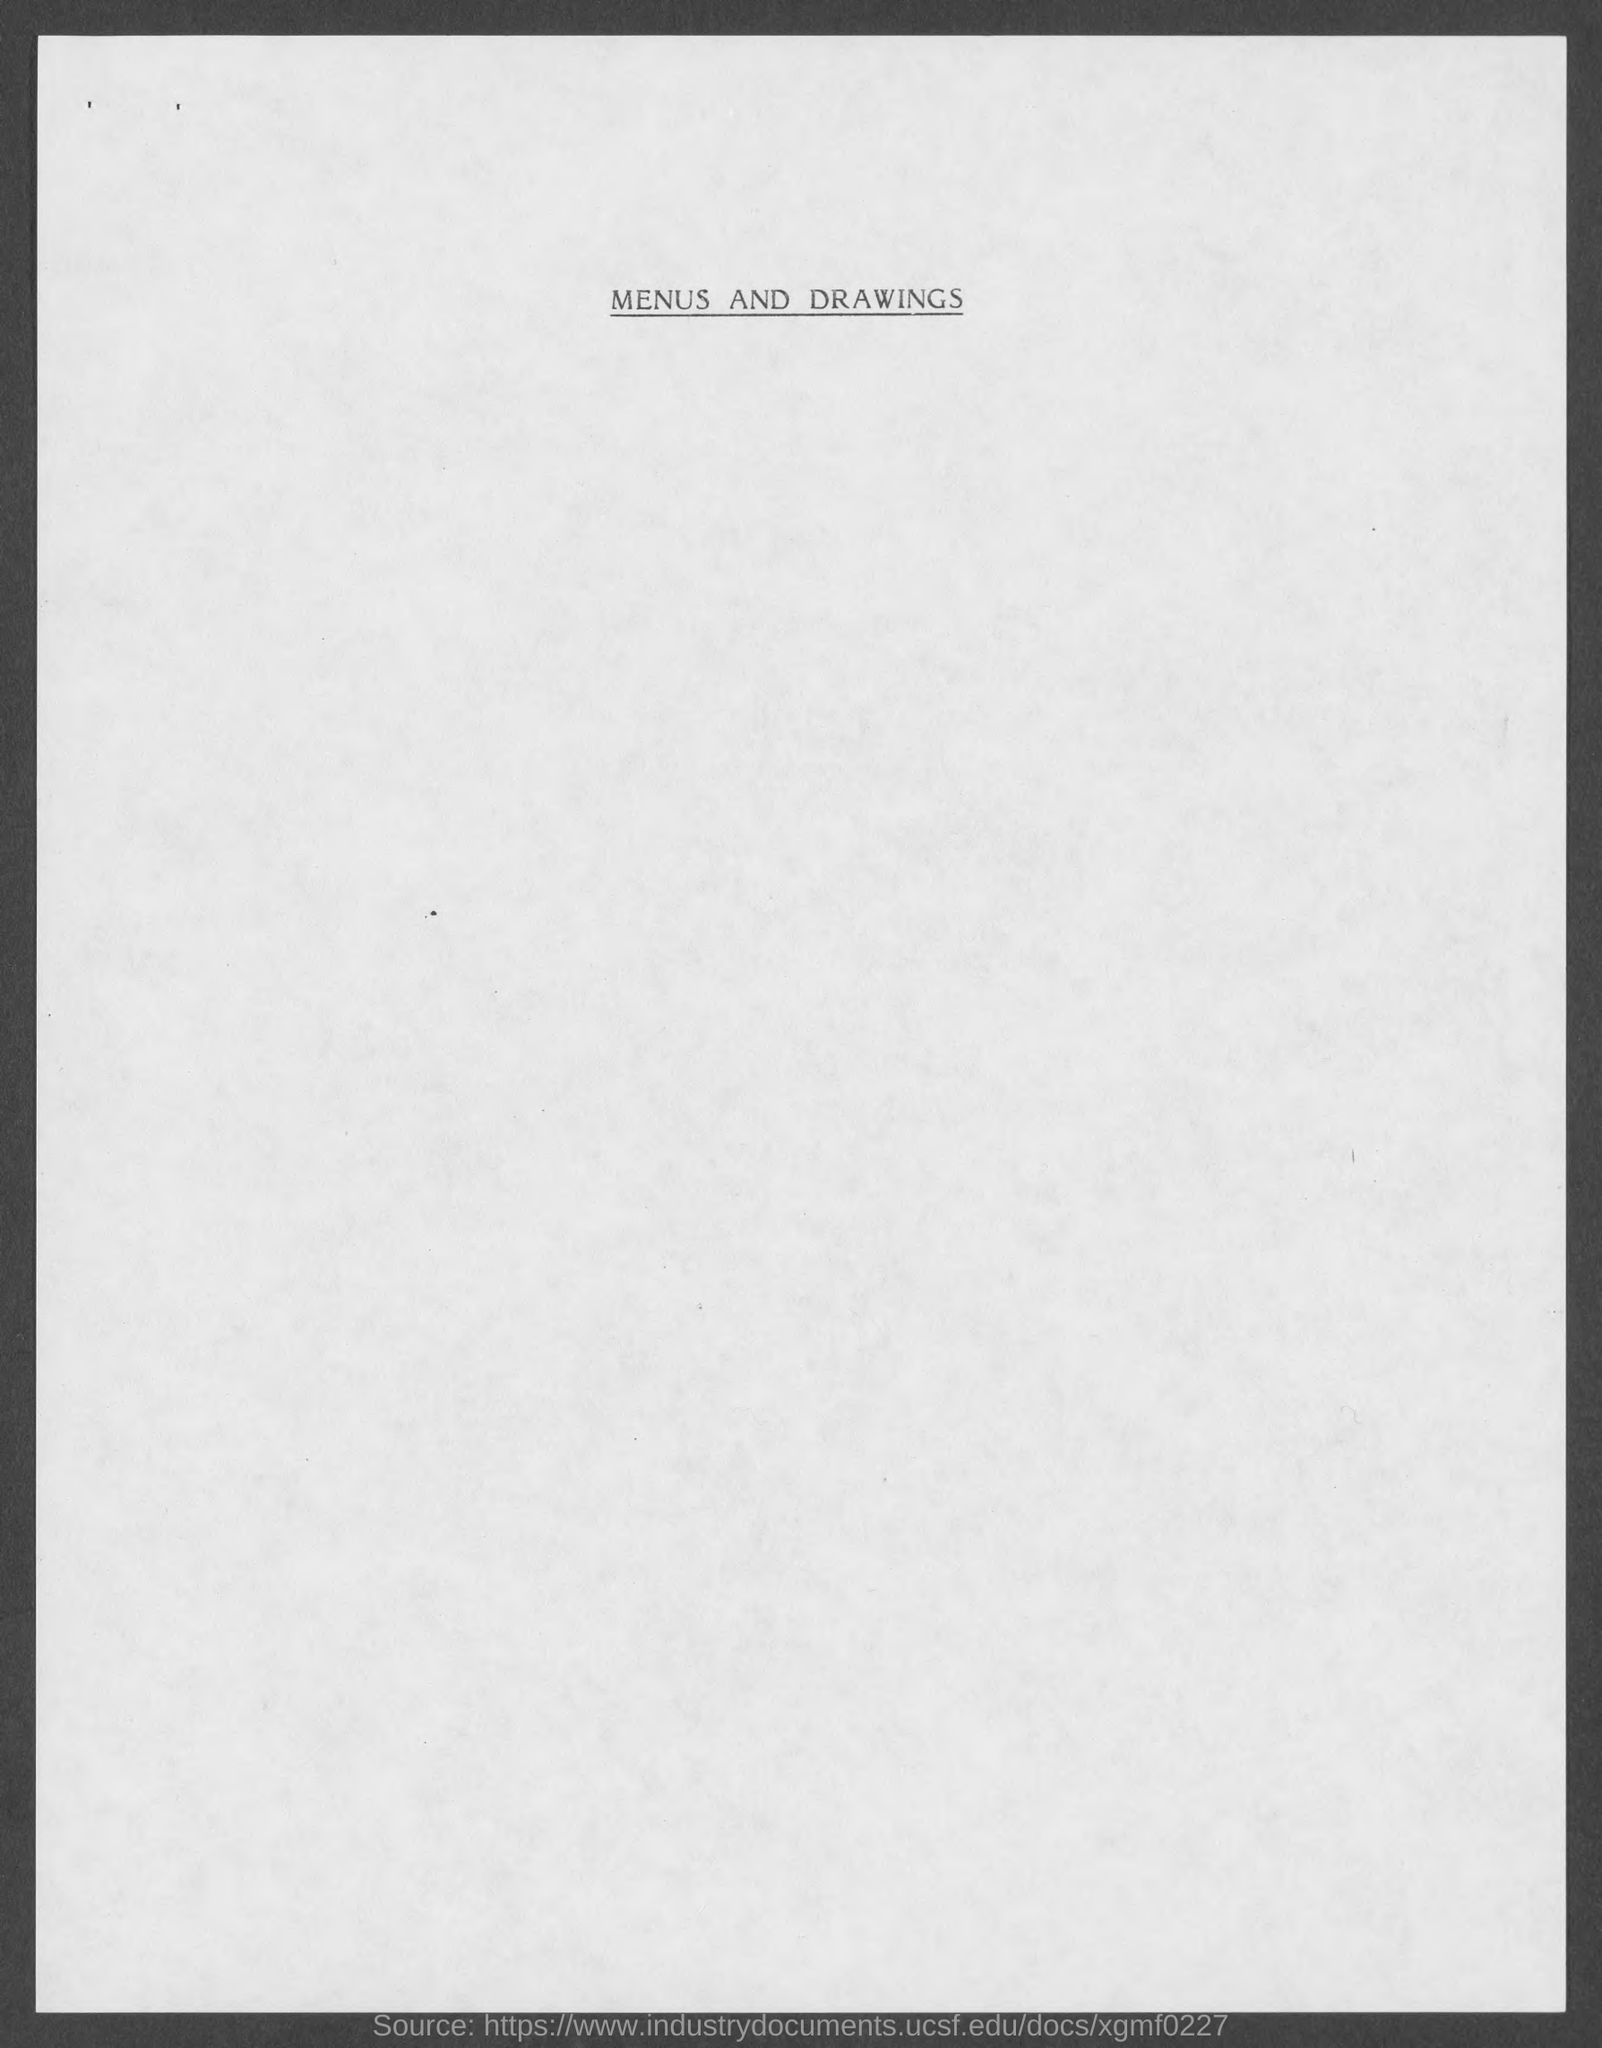What is the heading of document on top?
Make the answer very short. Menus and Drawings. 